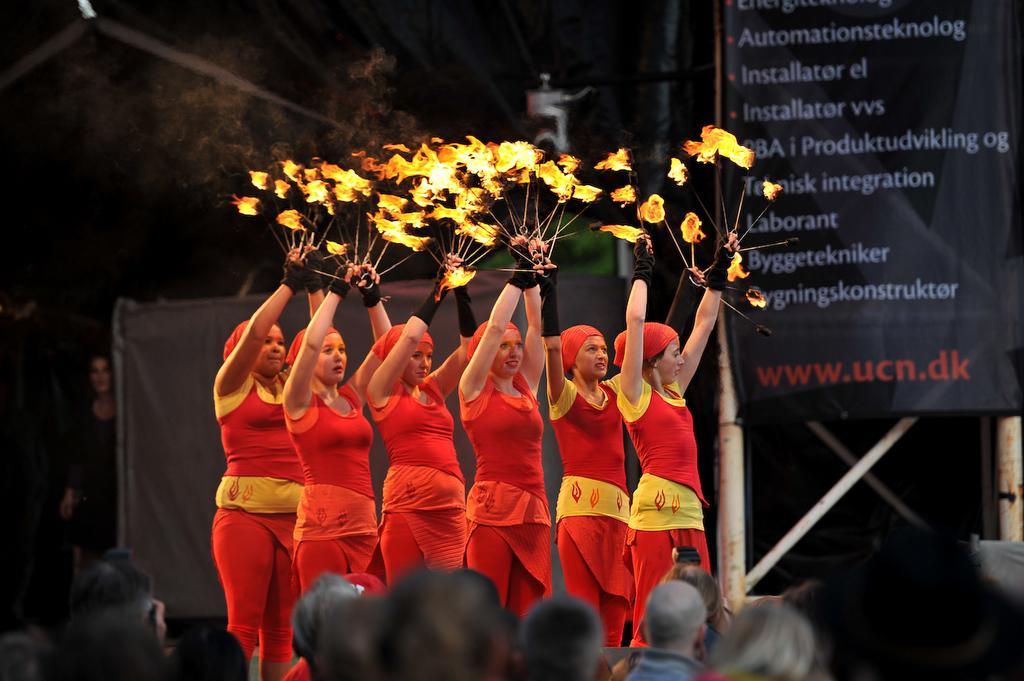Please provide a concise description of this image. In this picture I can see some women who are wearing red dress and holding the fire sticks. At the bottom I can see many people's head. On the right there is a banner which is placed on the pole. In the back there is a woman who is standing near to the cloth. 